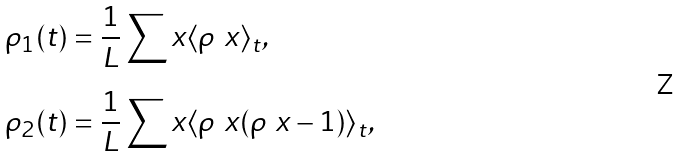Convert formula to latex. <formula><loc_0><loc_0><loc_500><loc_500>\rho _ { 1 } ( t ) & = \frac { 1 } { L } \sum _ { \ } x \langle \rho _ { \ } x \rangle _ { t } , \\ \rho _ { 2 } ( t ) & = \frac { 1 } { L } \sum _ { \ } x \langle \rho _ { \ } x ( \rho _ { \ } x - 1 ) \rangle _ { t } ,</formula> 